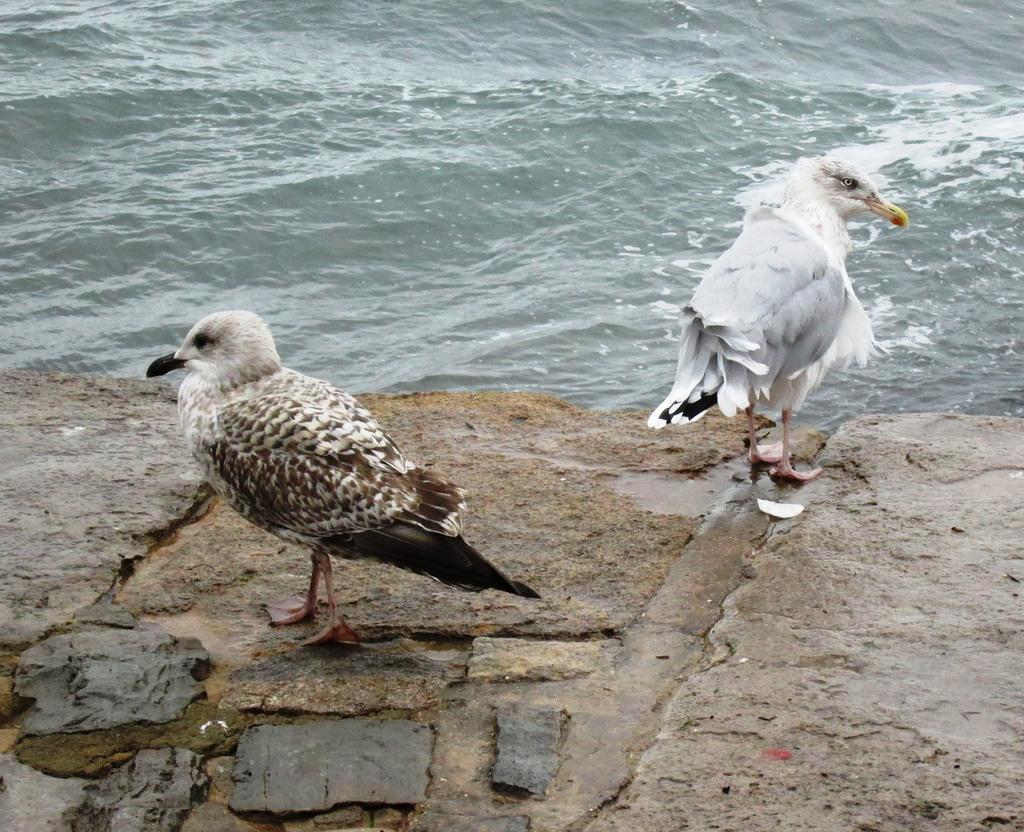Can you describe this image briefly? In this picture I can see couple of birds on the ground and I can see water. 